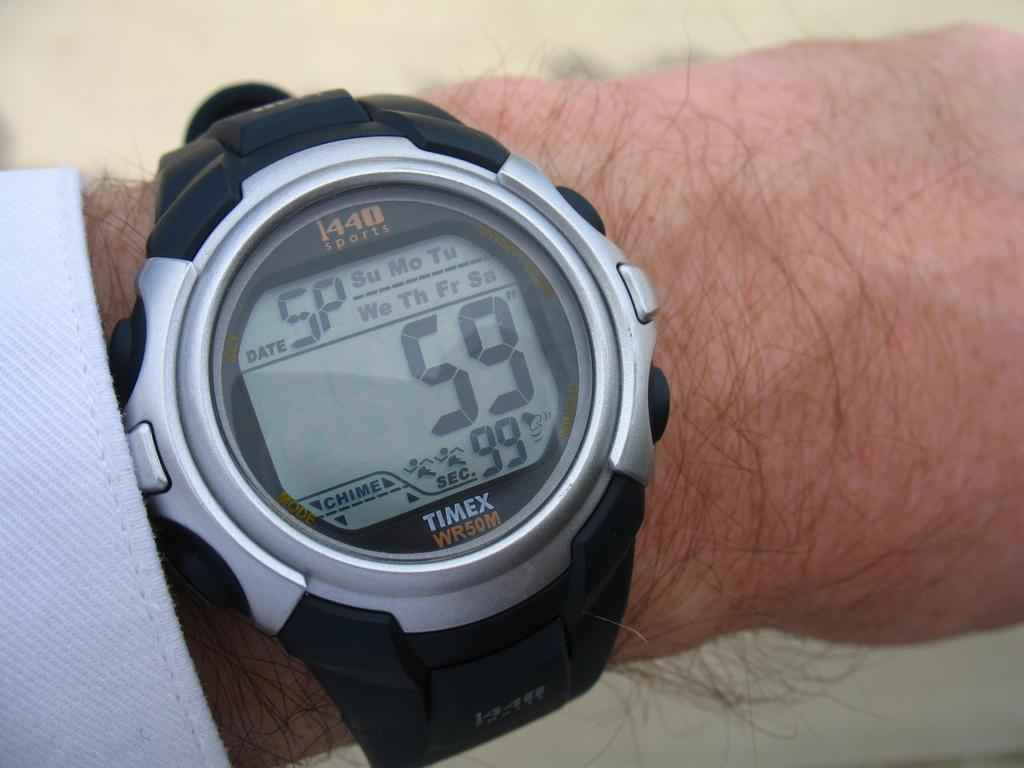<image>
Create a compact narrative representing the image presented. The black and silver TIMEX watch has a digital face with a chime button. 